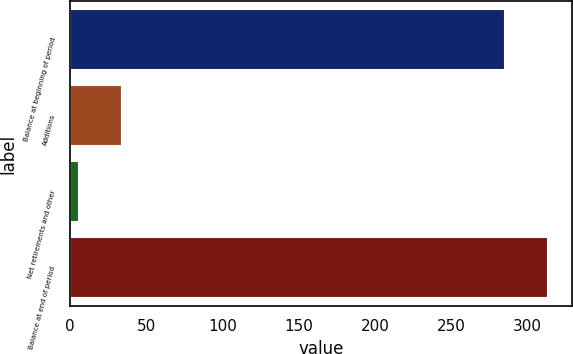<chart> <loc_0><loc_0><loc_500><loc_500><bar_chart><fcel>Balance at beginning of period<fcel>Additions<fcel>Net retirements and other<fcel>Balance at end of period<nl><fcel>285<fcel>34.5<fcel>6<fcel>313.5<nl></chart> 